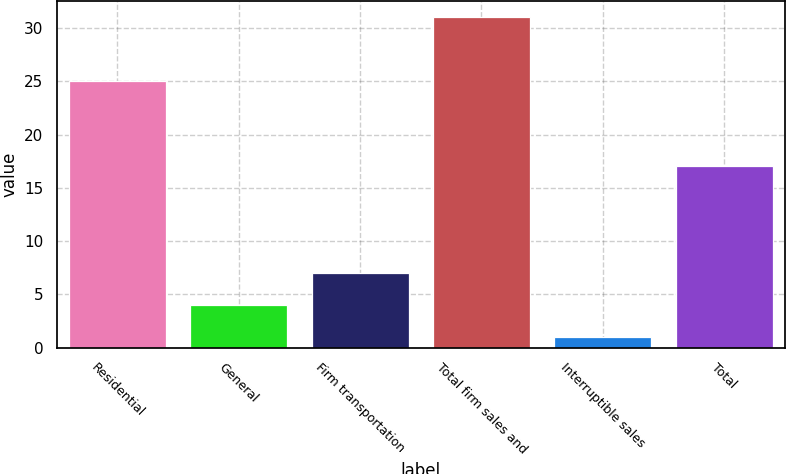Convert chart. <chart><loc_0><loc_0><loc_500><loc_500><bar_chart><fcel>Residential<fcel>General<fcel>Firm transportation<fcel>Total firm sales and<fcel>Interruptible sales<fcel>Total<nl><fcel>25<fcel>4<fcel>7<fcel>31<fcel>1<fcel>17<nl></chart> 